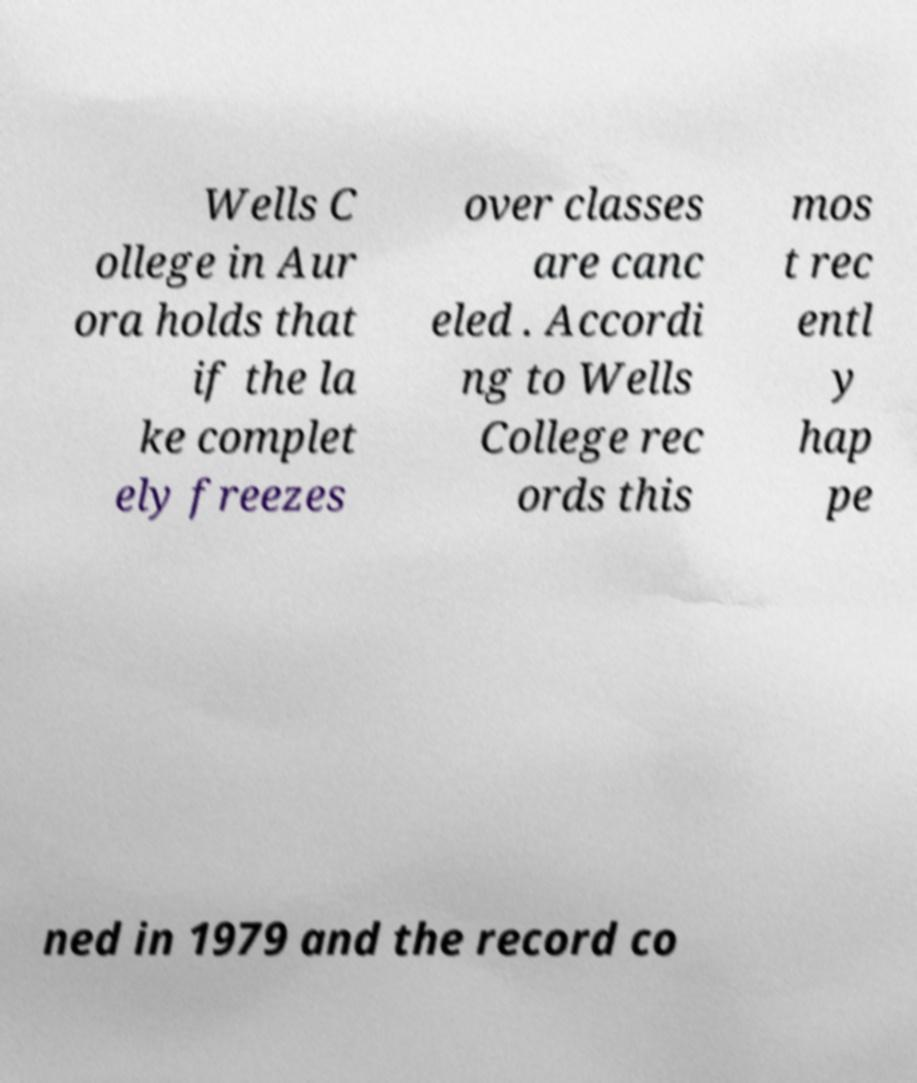Please read and relay the text visible in this image. What does it say? Wells C ollege in Aur ora holds that if the la ke complet ely freezes over classes are canc eled . Accordi ng to Wells College rec ords this mos t rec entl y hap pe ned in 1979 and the record co 